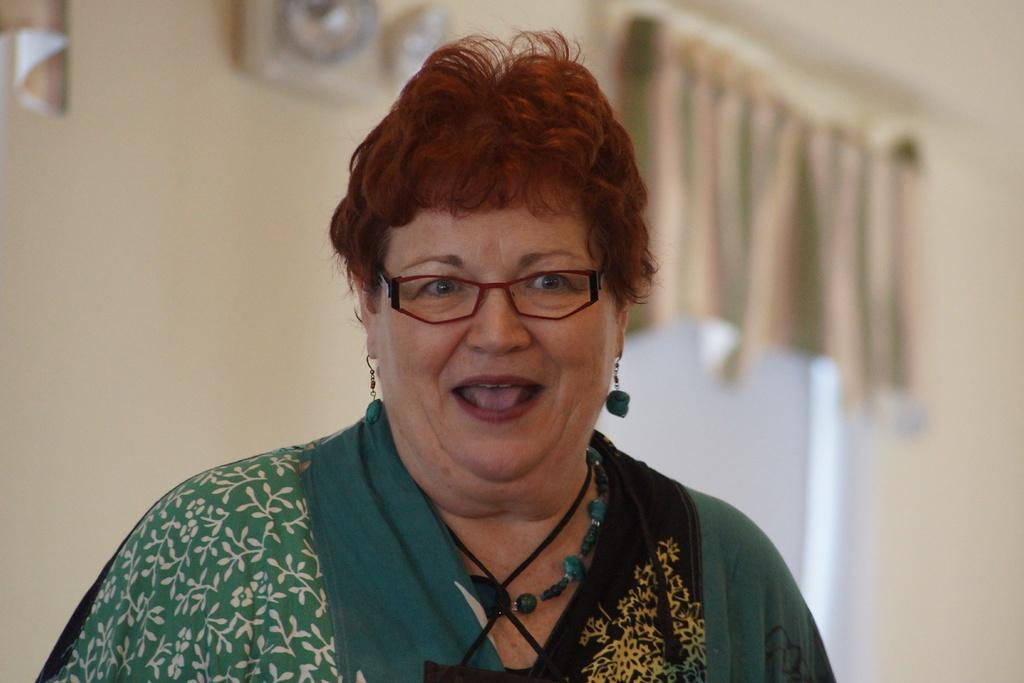What is the main subject of the image? The main subject of the image is a woman. What is the woman wearing on her face? The woman is wearing a spectacle. What is the woman doing with her mouth? The woman's mouth is open. What color is the dress the woman is wearing? The woman is wearing a green color dress. What can be seen in the background of the image? There is a wall, a window, and a curtain associated with the window in the background of the image. Can you tell me how many coughs the woman is experiencing in the image? There is no indication of coughing in the image, so it cannot be determined from the image. 